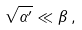Convert formula to latex. <formula><loc_0><loc_0><loc_500><loc_500>\sqrt { \alpha ^ { \prime } } \ll \beta \, ,</formula> 